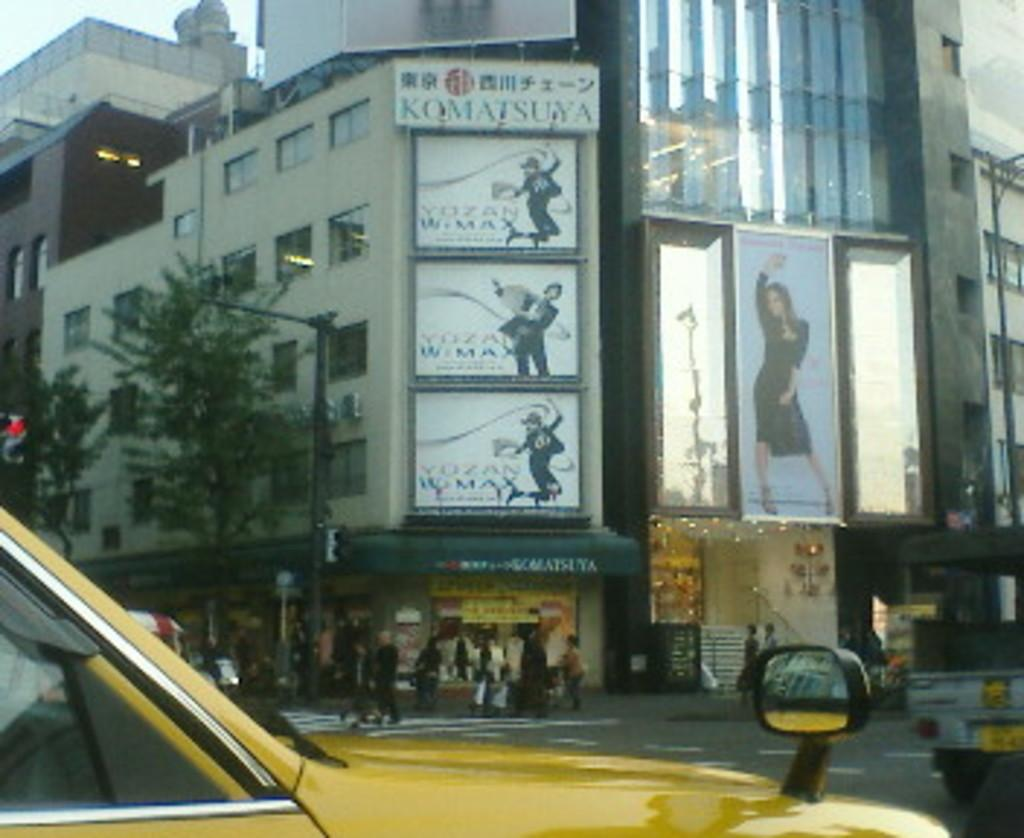<image>
Summarize the visual content of the image. A sign on the side of a building is for Komatsuya. 